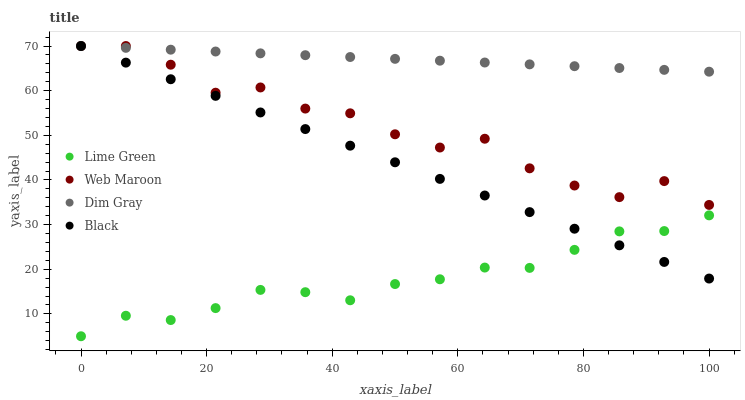Does Lime Green have the minimum area under the curve?
Answer yes or no. Yes. Does Dim Gray have the maximum area under the curve?
Answer yes or no. Yes. Does Dim Gray have the minimum area under the curve?
Answer yes or no. No. Does Lime Green have the maximum area under the curve?
Answer yes or no. No. Is Black the smoothest?
Answer yes or no. Yes. Is Web Maroon the roughest?
Answer yes or no. Yes. Is Dim Gray the smoothest?
Answer yes or no. No. Is Dim Gray the roughest?
Answer yes or no. No. Does Lime Green have the lowest value?
Answer yes or no. Yes. Does Dim Gray have the lowest value?
Answer yes or no. No. Does Black have the highest value?
Answer yes or no. Yes. Does Lime Green have the highest value?
Answer yes or no. No. Is Lime Green less than Web Maroon?
Answer yes or no. Yes. Is Web Maroon greater than Lime Green?
Answer yes or no. Yes. Does Black intersect Dim Gray?
Answer yes or no. Yes. Is Black less than Dim Gray?
Answer yes or no. No. Is Black greater than Dim Gray?
Answer yes or no. No. Does Lime Green intersect Web Maroon?
Answer yes or no. No. 